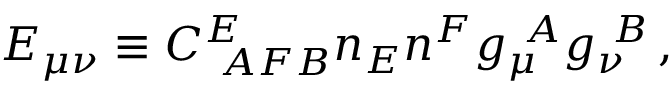Convert formula to latex. <formula><loc_0><loc_0><loc_500><loc_500>E _ { \mu \nu } \equiv C _ { A F B } ^ { E } n _ { E } n ^ { F } g _ { \mu } ^ { A } g _ { \nu } ^ { B } \, ,</formula> 